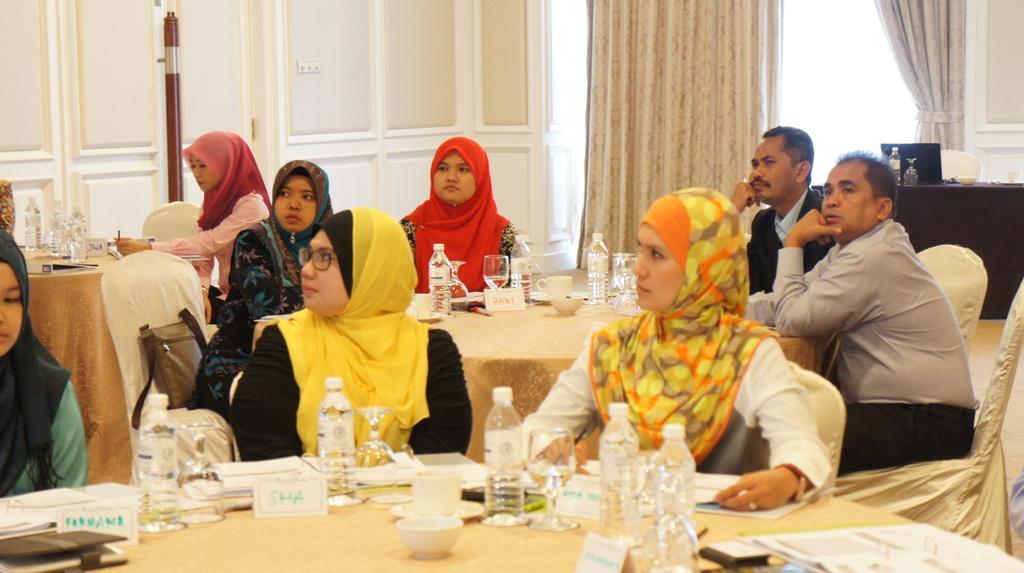How would you summarize this image in a sentence or two? In the image we can see there are people who are sitting on chair and on table there is water bottle, cup and pamphlets. 